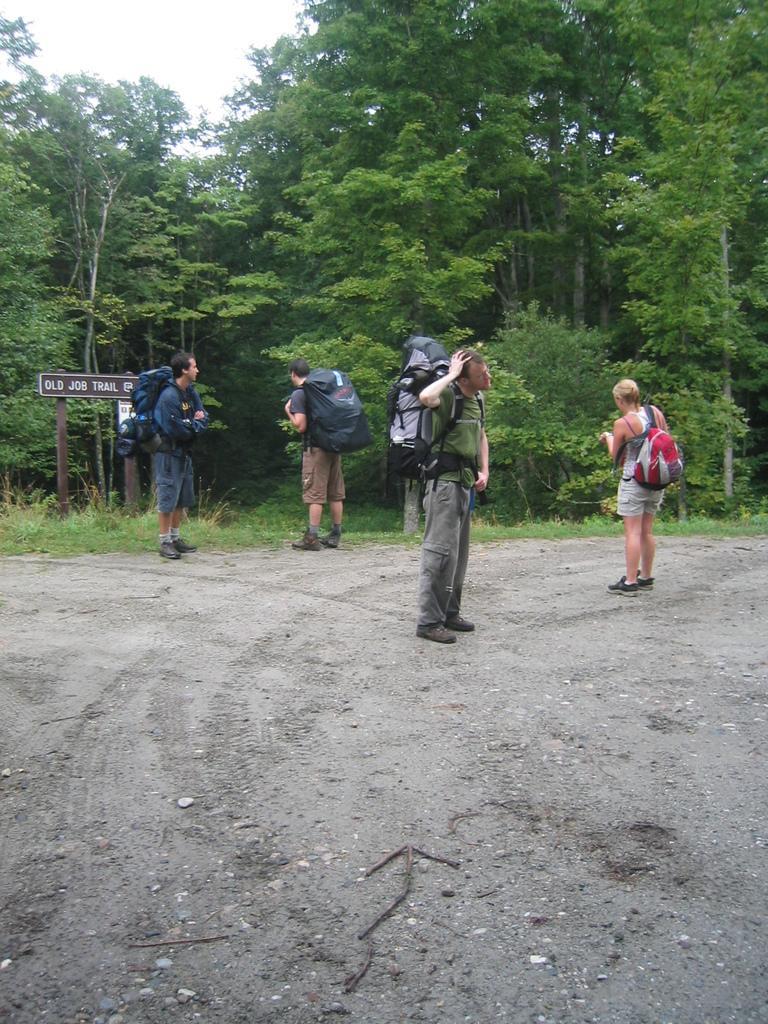In one or two sentences, can you explain what this image depicts? In this image I can see four people standing in a forest. Two people facing towards the back, two people facing towards the right and I can see trees and road at the bottom of the image and sky at the top of the image.  